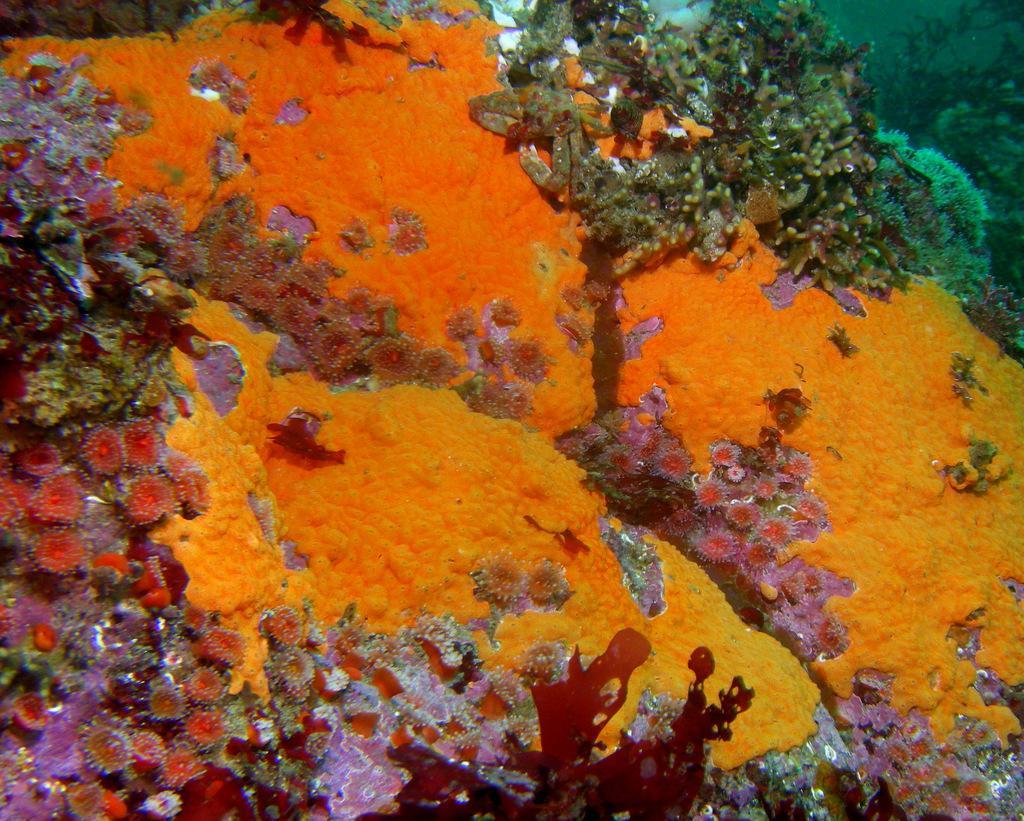In one or two sentences, can you explain what this image depicts? In this picture I can see corals under the water. 